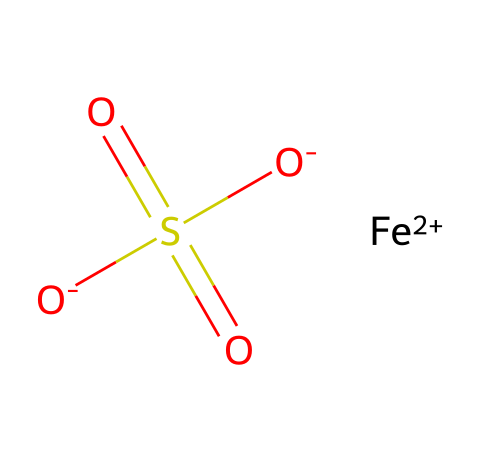What is the oxidation state of iron in this compound? The SMILES notation shows [Fe+2], indicating that the oxidation state of iron is +2.
Answer: +2 How many oxygen atoms are present in the molecule? Analyzing the structure, there are two oxygen atoms represented by [O-]S(=O)(=O)[O-], which indicates two negatively charged oxygen atoms.
Answer: 2 What is the primary function of this chemical in relation to heart health? Iron is primarily used to prevent or treat iron deficiency anemia, which can affect heart health by reducing oxygen transport.
Answer: prevent anemia Is this molecule ionic or covalent? The presence of charged species like [Fe+2] and [O-] suggests that this molecule is primarily ionic in nature.
Answer: ionic What does the 'S(=O)(=O)' in the SMILES represent? This portion represents a sulfur atom bonded to three oxygen atoms, two with double bonds and one with a single bond, indicating a sulfate group.
Answer: sulfate What type of supplement does this chemical represent? Given the iron content and its use in addressing iron deficiency, this chemical represents an iron supplement.
Answer: iron supplement How many total atoms are there in this molecule? Counting the atoms gives one iron, one sulfur, and four oxygen atoms, which totals six atoms in the molecule.
Answer: 6 